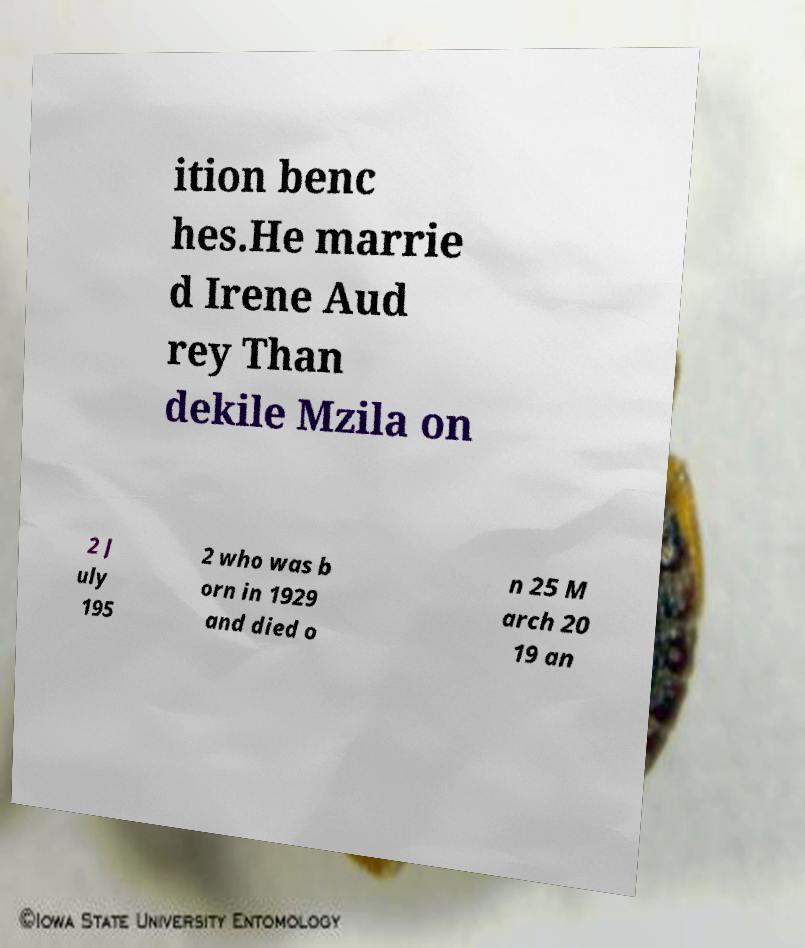Please identify and transcribe the text found in this image. ition benc hes.He marrie d Irene Aud rey Than dekile Mzila on 2 J uly 195 2 who was b orn in 1929 and died o n 25 M arch 20 19 an 